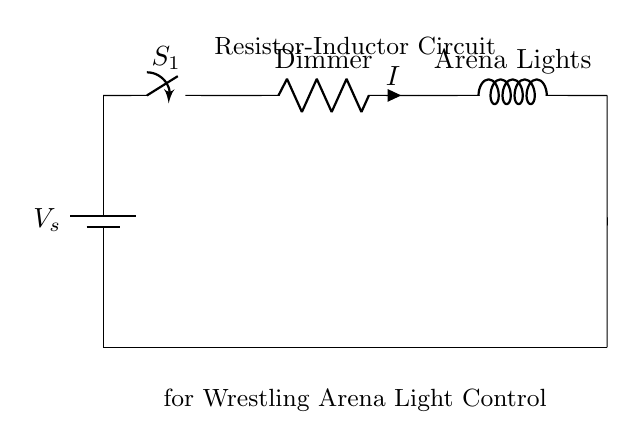What components are in this circuit? The circuit contains a battery, a switch, a resistor, and an inductor. These are the primary components visible in the diagram that form the circuit.
Answer: battery, switch, resistor, inductor What is the function of the resistor in this circuit? The resistor acts as a dimmer, controlling the current flow to the arena lights. By adjusting the resistance, the brightness of the lights can be varied, allowing for a smoother transition during entrances.
Answer: dimmer What type of circuit is this? This is a resistor-inductor circuit, which is specifically designed to control the dimming of lights. The combination of these two components influences the behavior of the circuit and how it responds to changing current.
Answer: resistor-inductor What does the switch do in this circuit? The switch allows the user to turn the circuit on or off, thereby controlling whether the arena lights are illuminated or dimmed. It provides a simple means to manage the activation of the circuit and the resulting light output.
Answer: turn on/off How does the inductor affect the circuit's performance? The inductor impacts the circuit's behavior by storing energy in a magnetic field, which smooths out the changes in current over time. This characteristic helps in regulating the brightness of the lights as it responds to the applied voltage and current dynamic.
Answer: smooths current What is the connection type between the components? The components are connected in series, meaning that the current flows through each component one after the other, creating a single pathway for the flow of electricity in the circuit.
Answer: series What happens to the light output when the resistance increases? When resistance increases, the current decreases, leading to a lower power supply to the arena lights, which results in dimmer lights. This relationship directly influences the brightness as governed by the principles of Ohm's Law and power calculations.
Answer: dimmer lights 